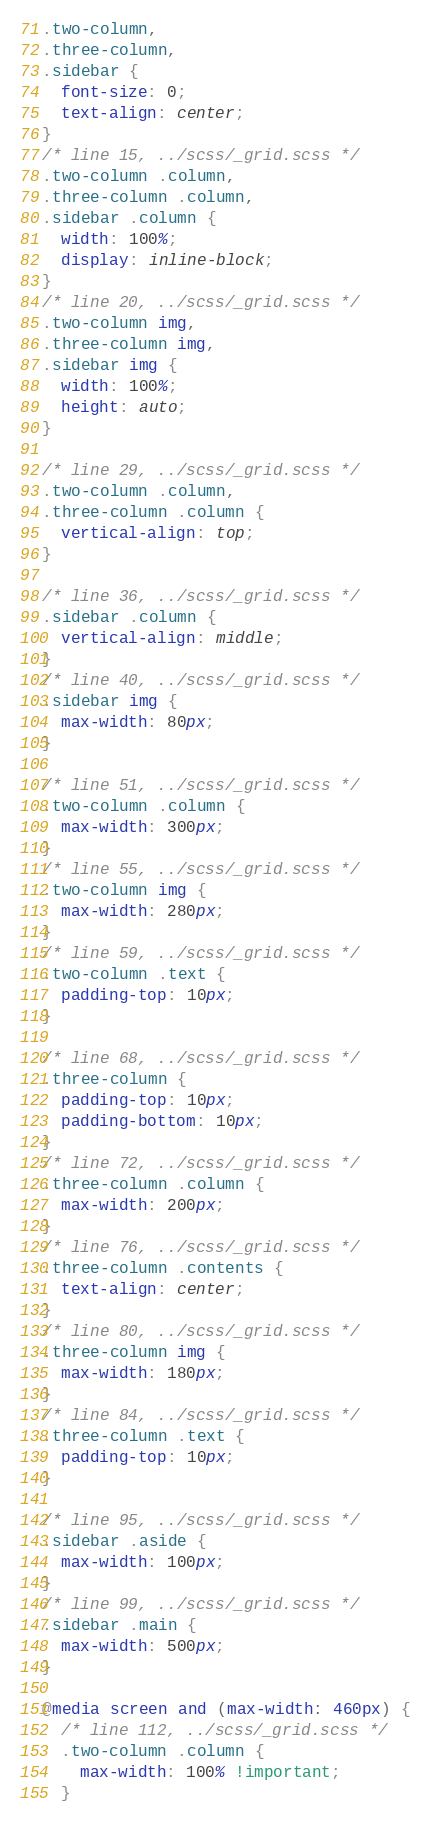<code> <loc_0><loc_0><loc_500><loc_500><_CSS_>.two-column,
.three-column,
.sidebar {
  font-size: 0;
  text-align: center;
}
/* line 15, ../scss/_grid.scss */
.two-column .column,
.three-column .column,
.sidebar .column {
  width: 100%;
  display: inline-block;
}
/* line 20, ../scss/_grid.scss */
.two-column img,
.three-column img,
.sidebar img {
  width: 100%;
  height: auto;
}

/* line 29, ../scss/_grid.scss */
.two-column .column,
.three-column .column {
  vertical-align: top;
}

/* line 36, ../scss/_grid.scss */
.sidebar .column {
  vertical-align: middle;
}
/* line 40, ../scss/_grid.scss */
.sidebar img {
  max-width: 80px;
}

/* line 51, ../scss/_grid.scss */
.two-column .column {
  max-width: 300px;
}
/* line 55, ../scss/_grid.scss */
.two-column img {
  max-width: 280px;
}
/* line 59, ../scss/_grid.scss */
.two-column .text {
  padding-top: 10px;
}

/* line 68, ../scss/_grid.scss */
.three-column {
  padding-top: 10px;
  padding-bottom: 10px;
}
/* line 72, ../scss/_grid.scss */
.three-column .column {
  max-width: 200px;
}
/* line 76, ../scss/_grid.scss */
.three-column .contents {
  text-align: center;
}
/* line 80, ../scss/_grid.scss */
.three-column img {
  max-width: 180px;
}
/* line 84, ../scss/_grid.scss */
.three-column .text {
  padding-top: 10px;
}

/* line 95, ../scss/_grid.scss */
.sidebar .aside {
  max-width: 100px;
}
/* line 99, ../scss/_grid.scss */
.sidebar .main {
  max-width: 500px;
}

@media screen and (max-width: 460px) {
  /* line 112, ../scss/_grid.scss */
  .two-column .column {
    max-width: 100% !important;
  }</code> 